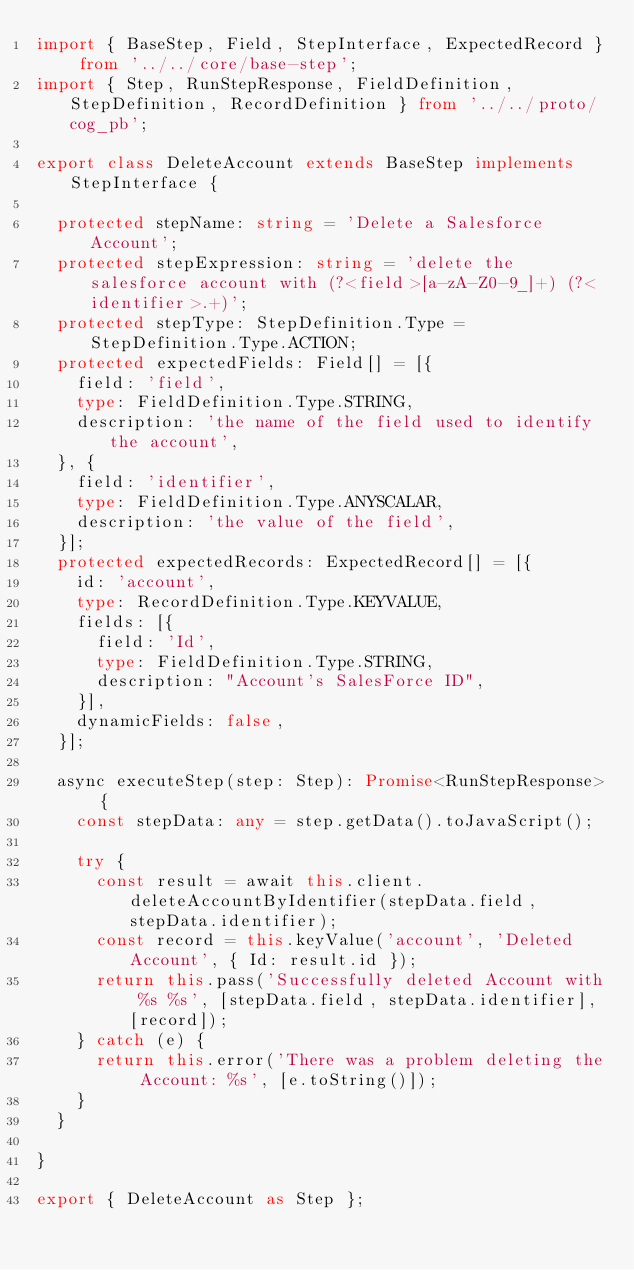Convert code to text. <code><loc_0><loc_0><loc_500><loc_500><_TypeScript_>import { BaseStep, Field, StepInterface, ExpectedRecord } from '../../core/base-step';
import { Step, RunStepResponse, FieldDefinition, StepDefinition, RecordDefinition } from '../../proto/cog_pb';

export class DeleteAccount extends BaseStep implements StepInterface {

  protected stepName: string = 'Delete a Salesforce Account';
  protected stepExpression: string = 'delete the salesforce account with (?<field>[a-zA-Z0-9_]+) (?<identifier>.+)';
  protected stepType: StepDefinition.Type = StepDefinition.Type.ACTION;
  protected expectedFields: Field[] = [{
    field: 'field',
    type: FieldDefinition.Type.STRING,
    description: 'the name of the field used to identify the account',
  }, {
    field: 'identifier',
    type: FieldDefinition.Type.ANYSCALAR,
    description: 'the value of the field',
  }];
  protected expectedRecords: ExpectedRecord[] = [{
    id: 'account',
    type: RecordDefinition.Type.KEYVALUE,
    fields: [{
      field: 'Id',
      type: FieldDefinition.Type.STRING,
      description: "Account's SalesForce ID",
    }],
    dynamicFields: false,
  }];

  async executeStep(step: Step): Promise<RunStepResponse> {
    const stepData: any = step.getData().toJavaScript();

    try {
      const result = await this.client.deleteAccountByIdentifier(stepData.field, stepData.identifier);
      const record = this.keyValue('account', 'Deleted Account', { Id: result.id });
      return this.pass('Successfully deleted Account with %s %s', [stepData.field, stepData.identifier], [record]);
    } catch (e) {
      return this.error('There was a problem deleting the Account: %s', [e.toString()]);
    }
  }

}

export { DeleteAccount as Step };
</code> 